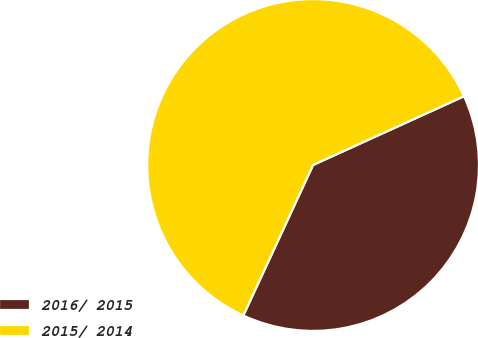Convert chart to OTSL. <chart><loc_0><loc_0><loc_500><loc_500><pie_chart><fcel>2016/ 2015<fcel>2015/ 2014<nl><fcel>38.71%<fcel>61.29%<nl></chart> 